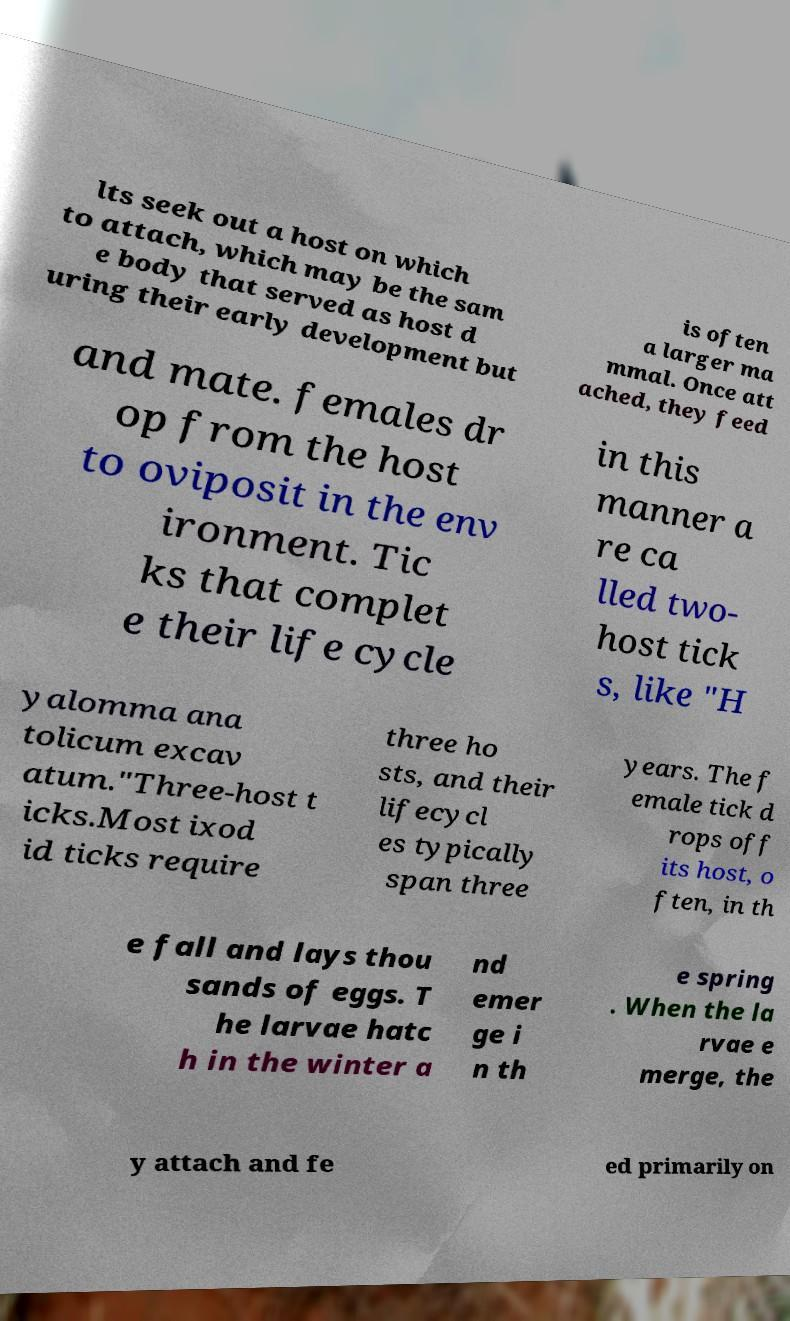For documentation purposes, I need the text within this image transcribed. Could you provide that? lts seek out a host on which to attach, which may be the sam e body that served as host d uring their early development but is often a larger ma mmal. Once att ached, they feed and mate. females dr op from the host to oviposit in the env ironment. Tic ks that complet e their life cycle in this manner a re ca lled two- host tick s, like "H yalomma ana tolicum excav atum."Three-host t icks.Most ixod id ticks require three ho sts, and their lifecycl es typically span three years. The f emale tick d rops off its host, o ften, in th e fall and lays thou sands of eggs. T he larvae hatc h in the winter a nd emer ge i n th e spring . When the la rvae e merge, the y attach and fe ed primarily on 